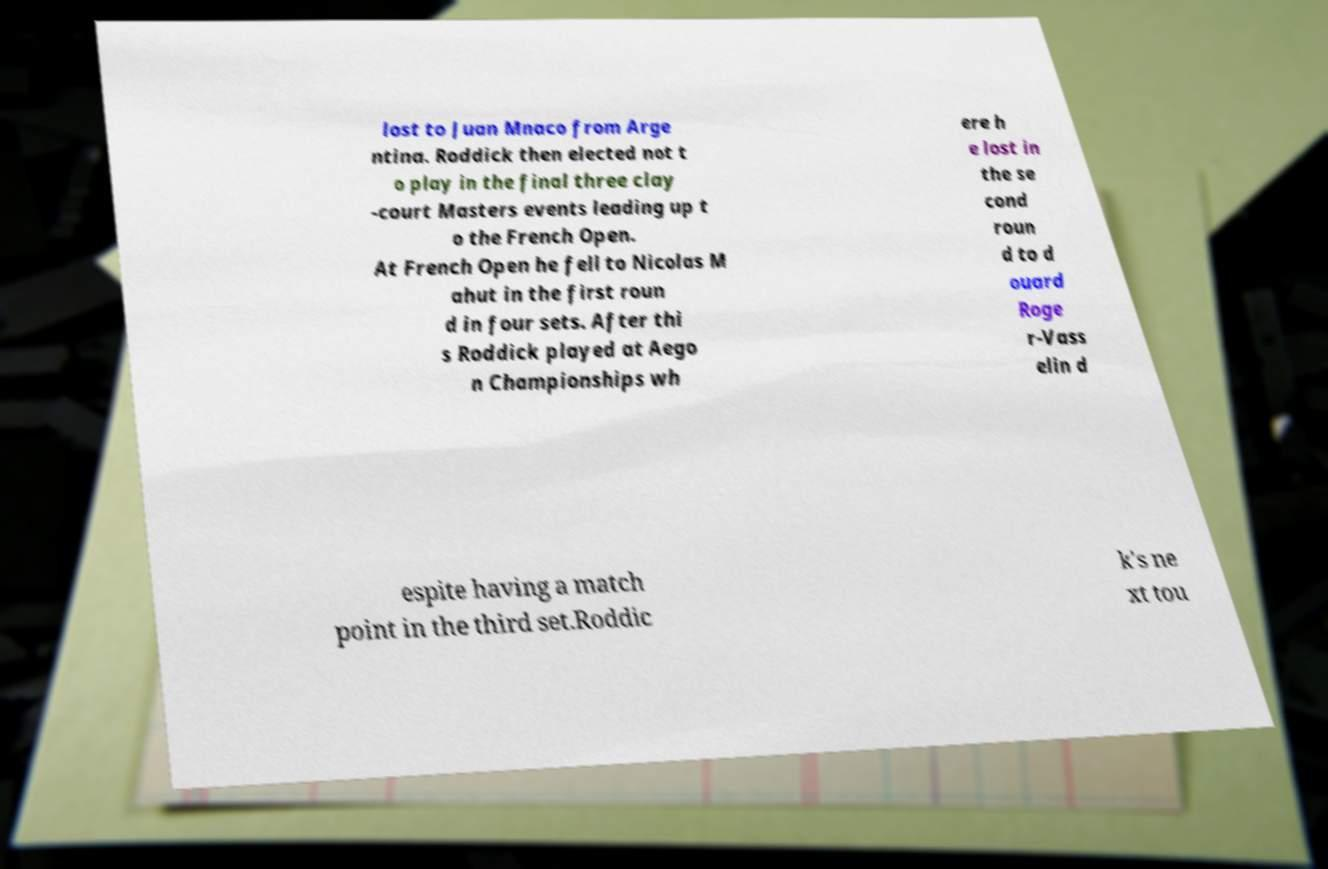Can you read and provide the text displayed in the image?This photo seems to have some interesting text. Can you extract and type it out for me? lost to Juan Mnaco from Arge ntina. Roddick then elected not t o play in the final three clay -court Masters events leading up t o the French Open. At French Open he fell to Nicolas M ahut in the first roun d in four sets. After thi s Roddick played at Aego n Championships wh ere h e lost in the se cond roun d to d ouard Roge r-Vass elin d espite having a match point in the third set.Roddic k's ne xt tou 